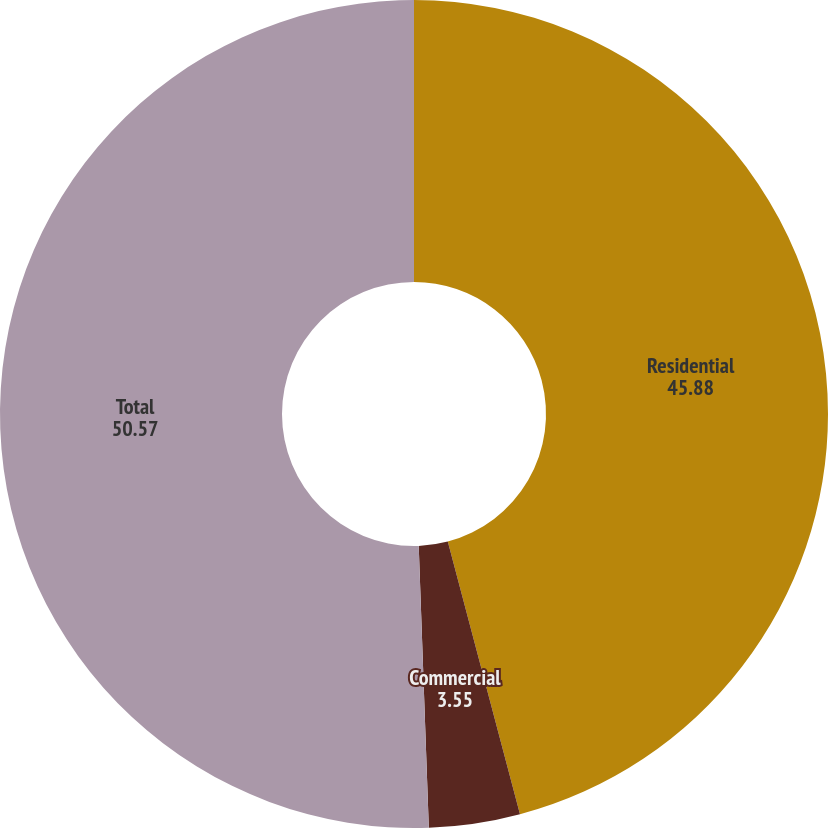Convert chart. <chart><loc_0><loc_0><loc_500><loc_500><pie_chart><fcel>Residential<fcel>Commercial<fcel>Total<nl><fcel>45.88%<fcel>3.55%<fcel>50.57%<nl></chart> 